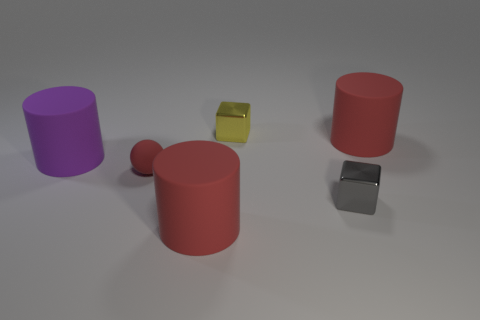Add 2 brown cylinders. How many objects exist? 8 Subtract all big purple cylinders. How many cylinders are left? 2 Subtract all spheres. How many objects are left? 5 Subtract 1 spheres. How many spheres are left? 0 Subtract all purple cylinders. How many cylinders are left? 2 Add 6 red spheres. How many red spheres exist? 7 Subtract 0 blue cubes. How many objects are left? 6 Subtract all brown blocks. Subtract all blue cylinders. How many blocks are left? 2 Subtract all cyan balls. How many red cylinders are left? 2 Subtract all big matte objects. Subtract all balls. How many objects are left? 2 